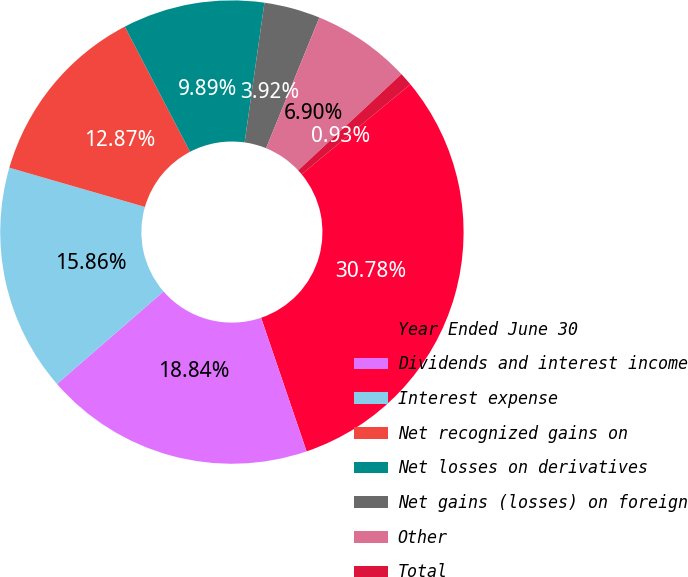Convert chart to OTSL. <chart><loc_0><loc_0><loc_500><loc_500><pie_chart><fcel>Year Ended June 30<fcel>Dividends and interest income<fcel>Interest expense<fcel>Net recognized gains on<fcel>Net losses on derivatives<fcel>Net gains (losses) on foreign<fcel>Other<fcel>Total<nl><fcel>30.78%<fcel>18.84%<fcel>15.86%<fcel>12.87%<fcel>9.89%<fcel>3.92%<fcel>6.9%<fcel>0.93%<nl></chart> 